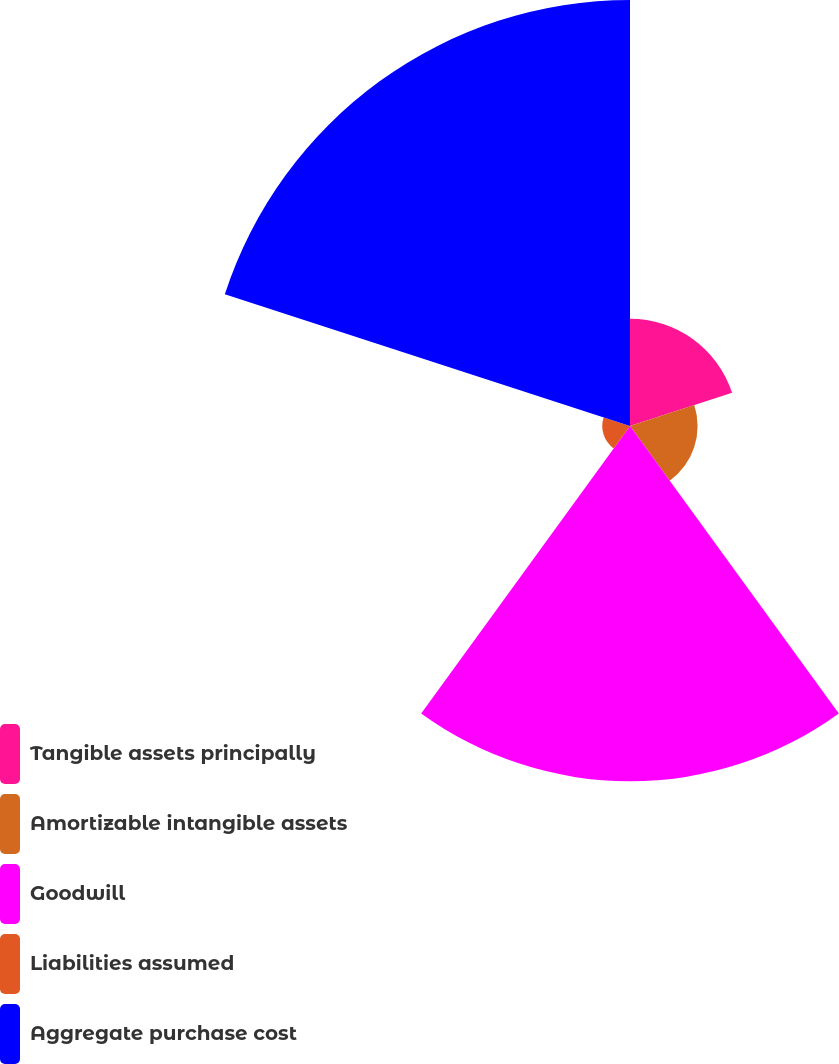Convert chart to OTSL. <chart><loc_0><loc_0><loc_500><loc_500><pie_chart><fcel>Tangible assets principally<fcel>Amortizable intangible assets<fcel>Goodwill<fcel>Liabilities assumed<fcel>Aggregate purchase cost<nl><fcel>10.91%<fcel>6.87%<fcel>36.11%<fcel>2.82%<fcel>43.3%<nl></chart> 